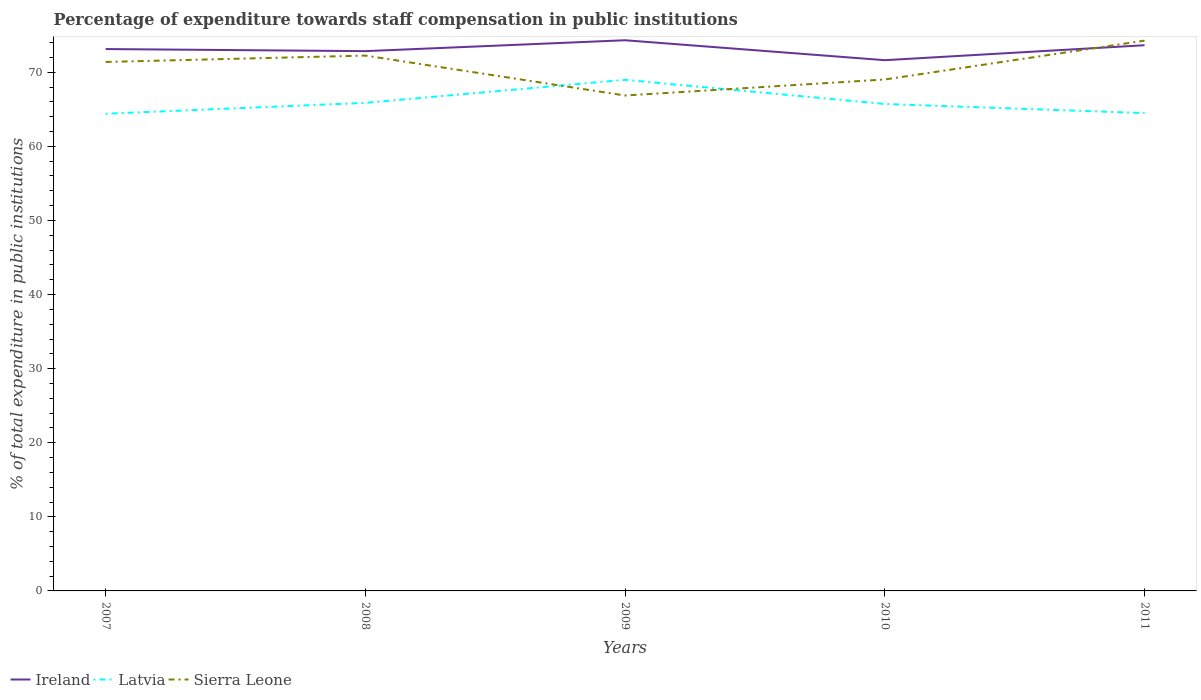Across all years, what is the maximum percentage of expenditure towards staff compensation in Latvia?
Offer a very short reply. 64.4. What is the total percentage of expenditure towards staff compensation in Sierra Leone in the graph?
Make the answer very short. -0.86. What is the difference between the highest and the second highest percentage of expenditure towards staff compensation in Ireland?
Ensure brevity in your answer.  2.69. Is the percentage of expenditure towards staff compensation in Latvia strictly greater than the percentage of expenditure towards staff compensation in Ireland over the years?
Give a very brief answer. Yes. What is the difference between two consecutive major ticks on the Y-axis?
Your answer should be compact. 10. Does the graph contain any zero values?
Keep it short and to the point. No. Does the graph contain grids?
Keep it short and to the point. No. Where does the legend appear in the graph?
Keep it short and to the point. Bottom left. What is the title of the graph?
Offer a very short reply. Percentage of expenditure towards staff compensation in public institutions. What is the label or title of the X-axis?
Your response must be concise. Years. What is the label or title of the Y-axis?
Your answer should be very brief. % of total expenditure in public institutions. What is the % of total expenditure in public institutions of Ireland in 2007?
Provide a succinct answer. 73.13. What is the % of total expenditure in public institutions in Latvia in 2007?
Your response must be concise. 64.4. What is the % of total expenditure in public institutions of Sierra Leone in 2007?
Offer a terse response. 71.39. What is the % of total expenditure in public institutions of Ireland in 2008?
Offer a terse response. 72.85. What is the % of total expenditure in public institutions of Latvia in 2008?
Your answer should be very brief. 65.87. What is the % of total expenditure in public institutions in Sierra Leone in 2008?
Your answer should be very brief. 72.25. What is the % of total expenditure in public institutions of Ireland in 2009?
Ensure brevity in your answer.  74.32. What is the % of total expenditure in public institutions in Latvia in 2009?
Your answer should be compact. 68.98. What is the % of total expenditure in public institutions of Sierra Leone in 2009?
Your response must be concise. 66.86. What is the % of total expenditure in public institutions in Ireland in 2010?
Your answer should be compact. 71.63. What is the % of total expenditure in public institutions in Latvia in 2010?
Your answer should be compact. 65.72. What is the % of total expenditure in public institutions in Sierra Leone in 2010?
Your answer should be compact. 69.03. What is the % of total expenditure in public institutions in Ireland in 2011?
Make the answer very short. 73.65. What is the % of total expenditure in public institutions of Latvia in 2011?
Ensure brevity in your answer.  64.49. What is the % of total expenditure in public institutions in Sierra Leone in 2011?
Ensure brevity in your answer.  74.27. Across all years, what is the maximum % of total expenditure in public institutions of Ireland?
Give a very brief answer. 74.32. Across all years, what is the maximum % of total expenditure in public institutions of Latvia?
Provide a short and direct response. 68.98. Across all years, what is the maximum % of total expenditure in public institutions of Sierra Leone?
Your response must be concise. 74.27. Across all years, what is the minimum % of total expenditure in public institutions of Ireland?
Your response must be concise. 71.63. Across all years, what is the minimum % of total expenditure in public institutions in Latvia?
Your response must be concise. 64.4. Across all years, what is the minimum % of total expenditure in public institutions of Sierra Leone?
Provide a succinct answer. 66.86. What is the total % of total expenditure in public institutions of Ireland in the graph?
Give a very brief answer. 365.59. What is the total % of total expenditure in public institutions in Latvia in the graph?
Offer a terse response. 329.47. What is the total % of total expenditure in public institutions of Sierra Leone in the graph?
Give a very brief answer. 353.8. What is the difference between the % of total expenditure in public institutions in Ireland in 2007 and that in 2008?
Your answer should be compact. 0.28. What is the difference between the % of total expenditure in public institutions in Latvia in 2007 and that in 2008?
Your answer should be very brief. -1.47. What is the difference between the % of total expenditure in public institutions in Sierra Leone in 2007 and that in 2008?
Your answer should be very brief. -0.86. What is the difference between the % of total expenditure in public institutions of Ireland in 2007 and that in 2009?
Your answer should be very brief. -1.19. What is the difference between the % of total expenditure in public institutions in Latvia in 2007 and that in 2009?
Offer a terse response. -4.58. What is the difference between the % of total expenditure in public institutions in Sierra Leone in 2007 and that in 2009?
Provide a short and direct response. 4.53. What is the difference between the % of total expenditure in public institutions in Ireland in 2007 and that in 2010?
Provide a succinct answer. 1.5. What is the difference between the % of total expenditure in public institutions of Latvia in 2007 and that in 2010?
Provide a succinct answer. -1.32. What is the difference between the % of total expenditure in public institutions of Sierra Leone in 2007 and that in 2010?
Offer a terse response. 2.36. What is the difference between the % of total expenditure in public institutions of Ireland in 2007 and that in 2011?
Provide a succinct answer. -0.52. What is the difference between the % of total expenditure in public institutions of Latvia in 2007 and that in 2011?
Ensure brevity in your answer.  -0.09. What is the difference between the % of total expenditure in public institutions of Sierra Leone in 2007 and that in 2011?
Your answer should be very brief. -2.88. What is the difference between the % of total expenditure in public institutions of Ireland in 2008 and that in 2009?
Offer a very short reply. -1.47. What is the difference between the % of total expenditure in public institutions of Latvia in 2008 and that in 2009?
Keep it short and to the point. -3.11. What is the difference between the % of total expenditure in public institutions of Sierra Leone in 2008 and that in 2009?
Ensure brevity in your answer.  5.39. What is the difference between the % of total expenditure in public institutions of Ireland in 2008 and that in 2010?
Your answer should be compact. 1.22. What is the difference between the % of total expenditure in public institutions of Latvia in 2008 and that in 2010?
Give a very brief answer. 0.15. What is the difference between the % of total expenditure in public institutions in Sierra Leone in 2008 and that in 2010?
Your answer should be compact. 3.23. What is the difference between the % of total expenditure in public institutions of Ireland in 2008 and that in 2011?
Provide a short and direct response. -0.8. What is the difference between the % of total expenditure in public institutions in Latvia in 2008 and that in 2011?
Offer a very short reply. 1.38. What is the difference between the % of total expenditure in public institutions in Sierra Leone in 2008 and that in 2011?
Provide a succinct answer. -2.02. What is the difference between the % of total expenditure in public institutions in Ireland in 2009 and that in 2010?
Make the answer very short. 2.69. What is the difference between the % of total expenditure in public institutions of Latvia in 2009 and that in 2010?
Your response must be concise. 3.26. What is the difference between the % of total expenditure in public institutions in Sierra Leone in 2009 and that in 2010?
Keep it short and to the point. -2.16. What is the difference between the % of total expenditure in public institutions in Ireland in 2009 and that in 2011?
Your response must be concise. 0.67. What is the difference between the % of total expenditure in public institutions in Latvia in 2009 and that in 2011?
Ensure brevity in your answer.  4.49. What is the difference between the % of total expenditure in public institutions in Sierra Leone in 2009 and that in 2011?
Your answer should be very brief. -7.41. What is the difference between the % of total expenditure in public institutions in Ireland in 2010 and that in 2011?
Give a very brief answer. -2.02. What is the difference between the % of total expenditure in public institutions in Latvia in 2010 and that in 2011?
Provide a short and direct response. 1.23. What is the difference between the % of total expenditure in public institutions in Sierra Leone in 2010 and that in 2011?
Provide a short and direct response. -5.24. What is the difference between the % of total expenditure in public institutions in Ireland in 2007 and the % of total expenditure in public institutions in Latvia in 2008?
Provide a succinct answer. 7.26. What is the difference between the % of total expenditure in public institutions of Ireland in 2007 and the % of total expenditure in public institutions of Sierra Leone in 2008?
Make the answer very short. 0.88. What is the difference between the % of total expenditure in public institutions of Latvia in 2007 and the % of total expenditure in public institutions of Sierra Leone in 2008?
Provide a short and direct response. -7.85. What is the difference between the % of total expenditure in public institutions in Ireland in 2007 and the % of total expenditure in public institutions in Latvia in 2009?
Give a very brief answer. 4.15. What is the difference between the % of total expenditure in public institutions in Ireland in 2007 and the % of total expenditure in public institutions in Sierra Leone in 2009?
Keep it short and to the point. 6.27. What is the difference between the % of total expenditure in public institutions in Latvia in 2007 and the % of total expenditure in public institutions in Sierra Leone in 2009?
Make the answer very short. -2.46. What is the difference between the % of total expenditure in public institutions of Ireland in 2007 and the % of total expenditure in public institutions of Latvia in 2010?
Make the answer very short. 7.41. What is the difference between the % of total expenditure in public institutions of Ireland in 2007 and the % of total expenditure in public institutions of Sierra Leone in 2010?
Ensure brevity in your answer.  4.11. What is the difference between the % of total expenditure in public institutions in Latvia in 2007 and the % of total expenditure in public institutions in Sierra Leone in 2010?
Offer a terse response. -4.62. What is the difference between the % of total expenditure in public institutions in Ireland in 2007 and the % of total expenditure in public institutions in Latvia in 2011?
Keep it short and to the point. 8.64. What is the difference between the % of total expenditure in public institutions of Ireland in 2007 and the % of total expenditure in public institutions of Sierra Leone in 2011?
Keep it short and to the point. -1.13. What is the difference between the % of total expenditure in public institutions in Latvia in 2007 and the % of total expenditure in public institutions in Sierra Leone in 2011?
Provide a short and direct response. -9.87. What is the difference between the % of total expenditure in public institutions in Ireland in 2008 and the % of total expenditure in public institutions in Latvia in 2009?
Provide a short and direct response. 3.87. What is the difference between the % of total expenditure in public institutions of Ireland in 2008 and the % of total expenditure in public institutions of Sierra Leone in 2009?
Provide a succinct answer. 5.99. What is the difference between the % of total expenditure in public institutions of Latvia in 2008 and the % of total expenditure in public institutions of Sierra Leone in 2009?
Your answer should be compact. -0.99. What is the difference between the % of total expenditure in public institutions in Ireland in 2008 and the % of total expenditure in public institutions in Latvia in 2010?
Your answer should be very brief. 7.13. What is the difference between the % of total expenditure in public institutions in Ireland in 2008 and the % of total expenditure in public institutions in Sierra Leone in 2010?
Ensure brevity in your answer.  3.83. What is the difference between the % of total expenditure in public institutions in Latvia in 2008 and the % of total expenditure in public institutions in Sierra Leone in 2010?
Offer a terse response. -3.15. What is the difference between the % of total expenditure in public institutions in Ireland in 2008 and the % of total expenditure in public institutions in Latvia in 2011?
Your response must be concise. 8.36. What is the difference between the % of total expenditure in public institutions in Ireland in 2008 and the % of total expenditure in public institutions in Sierra Leone in 2011?
Your response must be concise. -1.42. What is the difference between the % of total expenditure in public institutions in Latvia in 2008 and the % of total expenditure in public institutions in Sierra Leone in 2011?
Your response must be concise. -8.39. What is the difference between the % of total expenditure in public institutions in Ireland in 2009 and the % of total expenditure in public institutions in Latvia in 2010?
Ensure brevity in your answer.  8.6. What is the difference between the % of total expenditure in public institutions of Ireland in 2009 and the % of total expenditure in public institutions of Sierra Leone in 2010?
Make the answer very short. 5.3. What is the difference between the % of total expenditure in public institutions of Latvia in 2009 and the % of total expenditure in public institutions of Sierra Leone in 2010?
Provide a succinct answer. -0.04. What is the difference between the % of total expenditure in public institutions of Ireland in 2009 and the % of total expenditure in public institutions of Latvia in 2011?
Keep it short and to the point. 9.83. What is the difference between the % of total expenditure in public institutions of Ireland in 2009 and the % of total expenditure in public institutions of Sierra Leone in 2011?
Keep it short and to the point. 0.05. What is the difference between the % of total expenditure in public institutions in Latvia in 2009 and the % of total expenditure in public institutions in Sierra Leone in 2011?
Offer a terse response. -5.29. What is the difference between the % of total expenditure in public institutions in Ireland in 2010 and the % of total expenditure in public institutions in Latvia in 2011?
Provide a short and direct response. 7.14. What is the difference between the % of total expenditure in public institutions of Ireland in 2010 and the % of total expenditure in public institutions of Sierra Leone in 2011?
Your answer should be compact. -2.64. What is the difference between the % of total expenditure in public institutions in Latvia in 2010 and the % of total expenditure in public institutions in Sierra Leone in 2011?
Your response must be concise. -8.55. What is the average % of total expenditure in public institutions of Ireland per year?
Keep it short and to the point. 73.12. What is the average % of total expenditure in public institutions of Latvia per year?
Ensure brevity in your answer.  65.89. What is the average % of total expenditure in public institutions in Sierra Leone per year?
Make the answer very short. 70.76. In the year 2007, what is the difference between the % of total expenditure in public institutions of Ireland and % of total expenditure in public institutions of Latvia?
Keep it short and to the point. 8.73. In the year 2007, what is the difference between the % of total expenditure in public institutions in Ireland and % of total expenditure in public institutions in Sierra Leone?
Provide a succinct answer. 1.74. In the year 2007, what is the difference between the % of total expenditure in public institutions of Latvia and % of total expenditure in public institutions of Sierra Leone?
Your answer should be compact. -6.99. In the year 2008, what is the difference between the % of total expenditure in public institutions of Ireland and % of total expenditure in public institutions of Latvia?
Keep it short and to the point. 6.98. In the year 2008, what is the difference between the % of total expenditure in public institutions of Ireland and % of total expenditure in public institutions of Sierra Leone?
Keep it short and to the point. 0.6. In the year 2008, what is the difference between the % of total expenditure in public institutions of Latvia and % of total expenditure in public institutions of Sierra Leone?
Keep it short and to the point. -6.38. In the year 2009, what is the difference between the % of total expenditure in public institutions of Ireland and % of total expenditure in public institutions of Latvia?
Your response must be concise. 5.34. In the year 2009, what is the difference between the % of total expenditure in public institutions in Ireland and % of total expenditure in public institutions in Sierra Leone?
Offer a terse response. 7.46. In the year 2009, what is the difference between the % of total expenditure in public institutions in Latvia and % of total expenditure in public institutions in Sierra Leone?
Provide a succinct answer. 2.12. In the year 2010, what is the difference between the % of total expenditure in public institutions in Ireland and % of total expenditure in public institutions in Latvia?
Give a very brief answer. 5.91. In the year 2010, what is the difference between the % of total expenditure in public institutions in Ireland and % of total expenditure in public institutions in Sierra Leone?
Your answer should be very brief. 2.6. In the year 2010, what is the difference between the % of total expenditure in public institutions in Latvia and % of total expenditure in public institutions in Sierra Leone?
Provide a succinct answer. -3.31. In the year 2011, what is the difference between the % of total expenditure in public institutions of Ireland and % of total expenditure in public institutions of Latvia?
Keep it short and to the point. 9.16. In the year 2011, what is the difference between the % of total expenditure in public institutions of Ireland and % of total expenditure in public institutions of Sierra Leone?
Offer a very short reply. -0.62. In the year 2011, what is the difference between the % of total expenditure in public institutions in Latvia and % of total expenditure in public institutions in Sierra Leone?
Offer a terse response. -9.78. What is the ratio of the % of total expenditure in public institutions in Latvia in 2007 to that in 2008?
Provide a short and direct response. 0.98. What is the ratio of the % of total expenditure in public institutions in Sierra Leone in 2007 to that in 2008?
Your answer should be compact. 0.99. What is the ratio of the % of total expenditure in public institutions in Latvia in 2007 to that in 2009?
Ensure brevity in your answer.  0.93. What is the ratio of the % of total expenditure in public institutions of Sierra Leone in 2007 to that in 2009?
Make the answer very short. 1.07. What is the ratio of the % of total expenditure in public institutions in Ireland in 2007 to that in 2010?
Provide a succinct answer. 1.02. What is the ratio of the % of total expenditure in public institutions in Latvia in 2007 to that in 2010?
Make the answer very short. 0.98. What is the ratio of the % of total expenditure in public institutions in Sierra Leone in 2007 to that in 2010?
Provide a succinct answer. 1.03. What is the ratio of the % of total expenditure in public institutions of Ireland in 2007 to that in 2011?
Make the answer very short. 0.99. What is the ratio of the % of total expenditure in public institutions of Latvia in 2007 to that in 2011?
Your answer should be compact. 1. What is the ratio of the % of total expenditure in public institutions of Sierra Leone in 2007 to that in 2011?
Ensure brevity in your answer.  0.96. What is the ratio of the % of total expenditure in public institutions of Ireland in 2008 to that in 2009?
Give a very brief answer. 0.98. What is the ratio of the % of total expenditure in public institutions of Latvia in 2008 to that in 2009?
Offer a very short reply. 0.95. What is the ratio of the % of total expenditure in public institutions in Sierra Leone in 2008 to that in 2009?
Offer a very short reply. 1.08. What is the ratio of the % of total expenditure in public institutions of Ireland in 2008 to that in 2010?
Provide a short and direct response. 1.02. What is the ratio of the % of total expenditure in public institutions in Sierra Leone in 2008 to that in 2010?
Provide a short and direct response. 1.05. What is the ratio of the % of total expenditure in public institutions of Ireland in 2008 to that in 2011?
Provide a short and direct response. 0.99. What is the ratio of the % of total expenditure in public institutions in Latvia in 2008 to that in 2011?
Keep it short and to the point. 1.02. What is the ratio of the % of total expenditure in public institutions of Sierra Leone in 2008 to that in 2011?
Your answer should be very brief. 0.97. What is the ratio of the % of total expenditure in public institutions in Ireland in 2009 to that in 2010?
Your answer should be very brief. 1.04. What is the ratio of the % of total expenditure in public institutions in Latvia in 2009 to that in 2010?
Your response must be concise. 1.05. What is the ratio of the % of total expenditure in public institutions of Sierra Leone in 2009 to that in 2010?
Give a very brief answer. 0.97. What is the ratio of the % of total expenditure in public institutions of Ireland in 2009 to that in 2011?
Offer a terse response. 1.01. What is the ratio of the % of total expenditure in public institutions of Latvia in 2009 to that in 2011?
Provide a succinct answer. 1.07. What is the ratio of the % of total expenditure in public institutions in Sierra Leone in 2009 to that in 2011?
Make the answer very short. 0.9. What is the ratio of the % of total expenditure in public institutions in Ireland in 2010 to that in 2011?
Provide a succinct answer. 0.97. What is the ratio of the % of total expenditure in public institutions in Latvia in 2010 to that in 2011?
Your response must be concise. 1.02. What is the ratio of the % of total expenditure in public institutions of Sierra Leone in 2010 to that in 2011?
Make the answer very short. 0.93. What is the difference between the highest and the second highest % of total expenditure in public institutions of Ireland?
Make the answer very short. 0.67. What is the difference between the highest and the second highest % of total expenditure in public institutions of Latvia?
Give a very brief answer. 3.11. What is the difference between the highest and the second highest % of total expenditure in public institutions in Sierra Leone?
Offer a terse response. 2.02. What is the difference between the highest and the lowest % of total expenditure in public institutions in Ireland?
Your answer should be very brief. 2.69. What is the difference between the highest and the lowest % of total expenditure in public institutions in Latvia?
Your answer should be very brief. 4.58. What is the difference between the highest and the lowest % of total expenditure in public institutions of Sierra Leone?
Offer a very short reply. 7.41. 